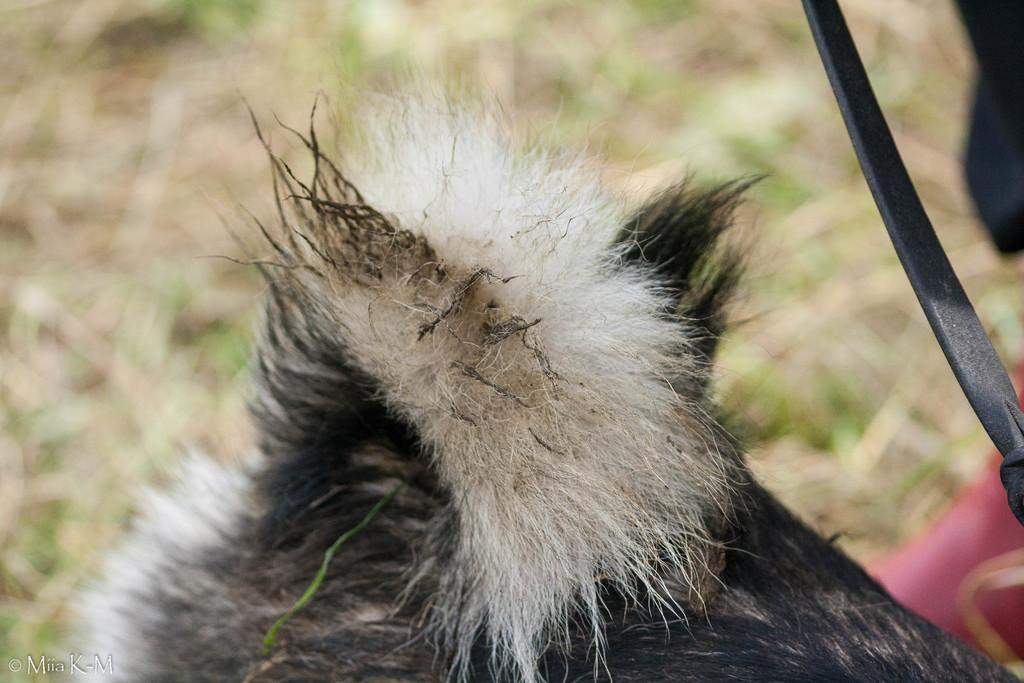What type of animal is in the image? The type of animal cannot be determined from the provided facts. What else can be seen in the image besides the animal? There is a cable wire in the image. Can you describe the background of the image? The background of the image is blurred. What color is the ink used to write the animal's name in the image? There is no ink or writing present in the image, as it features an animal and a cable wire with a blurred background. 